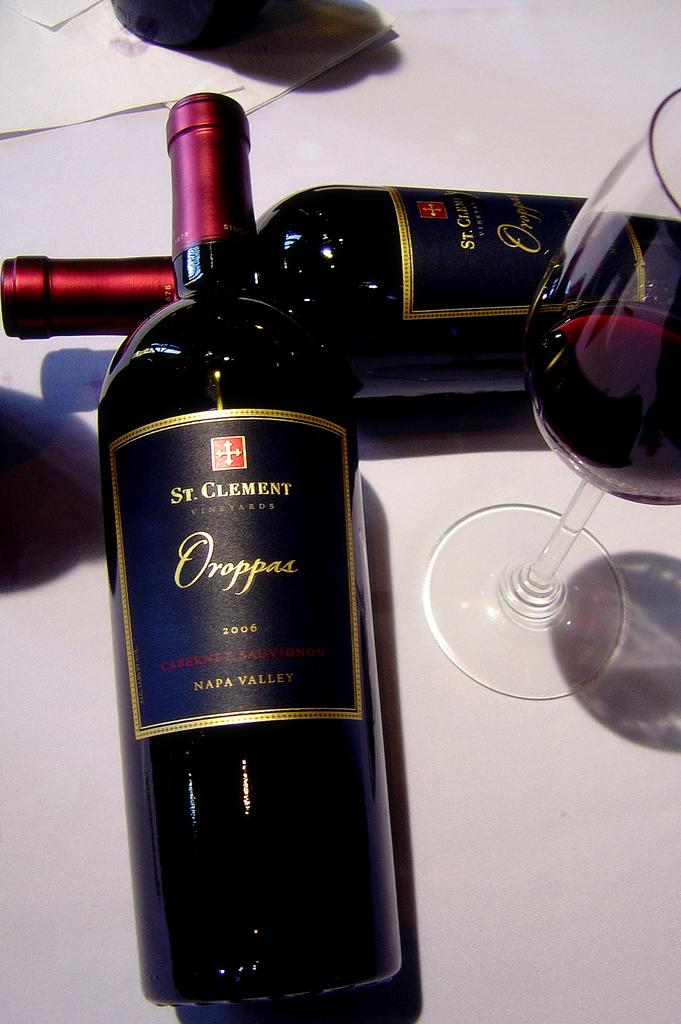How many bottles can be seen in the image? There are two bottles in the image. What is contained in the glass in the image? There is a drink in the glass. What type of items are present in the image that might be related to communication? There are envelopes in the image. Can you describe the unspecified object in the image? Unfortunately, the provided facts do not specify the nature of the unspecified object. On what surface are all of these items placed? All of these items are placed on a surface. What type of duck can be seen swimming in the glass in the image? There is no duck present in the image; the glass contains a drink. Is the gun used to shoot the toad in the image? There is no gun or toad present in the image. 